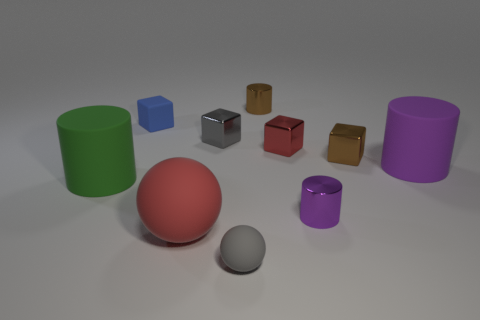What is the material of the tiny object that is the same color as the small matte ball?
Provide a succinct answer. Metal. Are there more metal cylinders that are on the right side of the big purple object than brown metal objects behind the blue block?
Give a very brief answer. No. What number of things are either red things or tiny purple shiny cylinders?
Provide a short and direct response. 3. What number of other objects are the same color as the small ball?
Make the answer very short. 1. What shape is the green thing that is the same size as the red matte sphere?
Provide a succinct answer. Cylinder. There is a block that is on the right side of the small purple cylinder; what is its color?
Keep it short and to the point. Brown. How many things are small cubes to the right of the blue object or cylinders to the left of the tiny red cube?
Ensure brevity in your answer.  5. Do the gray matte object and the purple matte object have the same size?
Keep it short and to the point. No. How many cubes are either purple objects or small gray things?
Offer a very short reply. 1. What number of small things are behind the small gray ball and in front of the brown shiny cylinder?
Give a very brief answer. 5. 